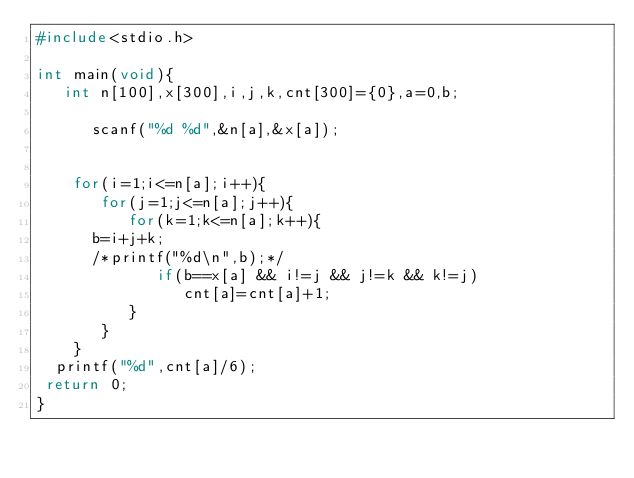<code> <loc_0><loc_0><loc_500><loc_500><_C_>#include<stdio.h>

int main(void){
   int n[100],x[300],i,j,k,cnt[300]={0},a=0,b;

      scanf("%d %d",&n[a],&x[a]);
      
 
    for(i=1;i<=n[a];i++){
       for(j=1;j<=n[a];j++){
          for(k=1;k<=n[a];k++){
			b=i+j+k;
			/*printf("%d\n",b);*/
             if(b==x[a] && i!=j && j!=k && k!=j)
                cnt[a]=cnt[a]+1;
          }
       }
    }
  printf("%d",cnt[a]/6);
 return 0;
}
   
</code> 